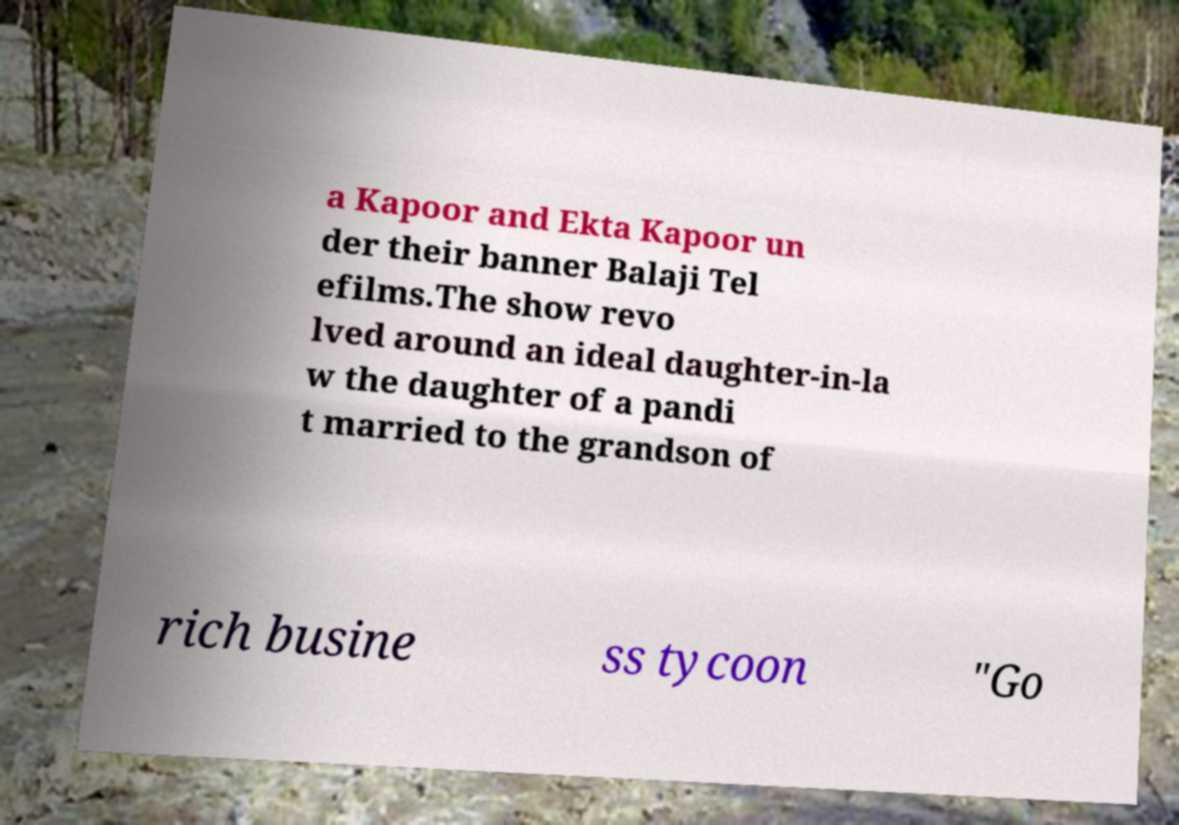I need the written content from this picture converted into text. Can you do that? a Kapoor and Ekta Kapoor un der their banner Balaji Tel efilms.The show revo lved around an ideal daughter-in-la w the daughter of a pandi t married to the grandson of rich busine ss tycoon "Go 